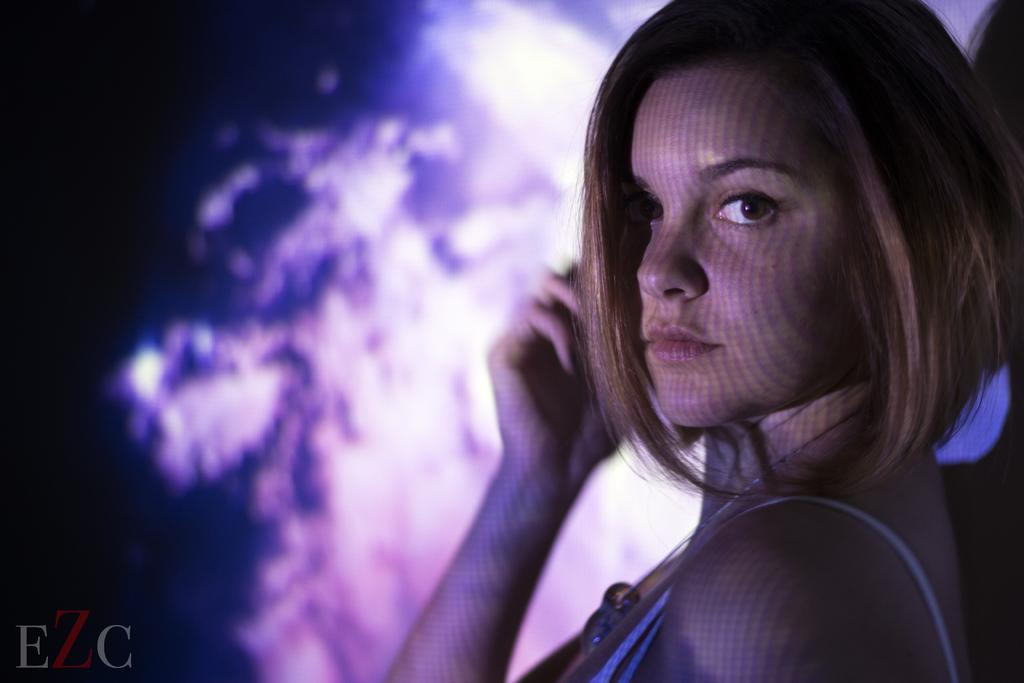Could you give a brief overview of what you see in this image? In this picture we can see a woman here, at the left bottom there is some text, we can see a blurry background here. 